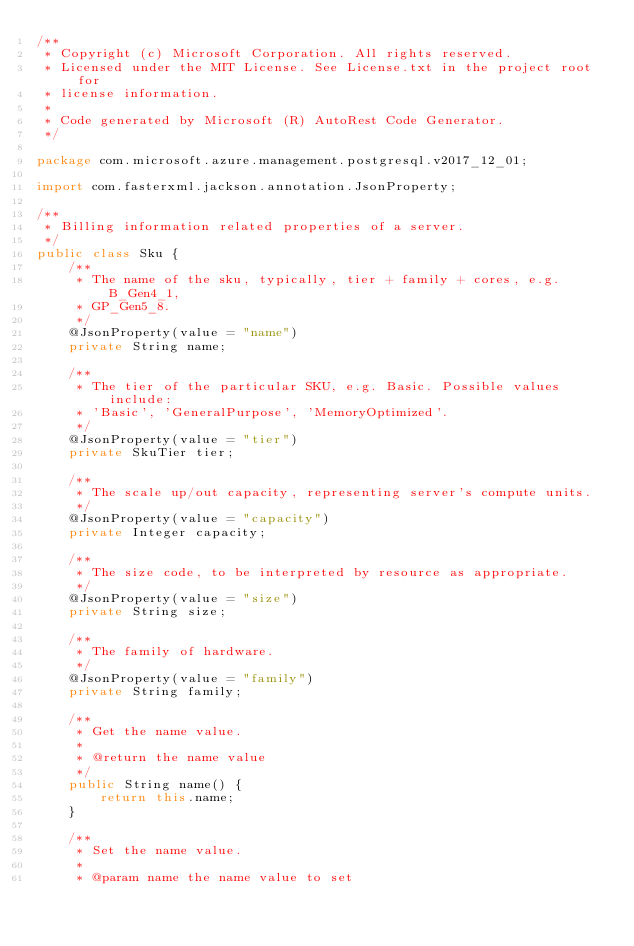<code> <loc_0><loc_0><loc_500><loc_500><_Java_>/**
 * Copyright (c) Microsoft Corporation. All rights reserved.
 * Licensed under the MIT License. See License.txt in the project root for
 * license information.
 *
 * Code generated by Microsoft (R) AutoRest Code Generator.
 */

package com.microsoft.azure.management.postgresql.v2017_12_01;

import com.fasterxml.jackson.annotation.JsonProperty;

/**
 * Billing information related properties of a server.
 */
public class Sku {
    /**
     * The name of the sku, typically, tier + family + cores, e.g. B_Gen4_1,
     * GP_Gen5_8.
     */
    @JsonProperty(value = "name")
    private String name;

    /**
     * The tier of the particular SKU, e.g. Basic. Possible values include:
     * 'Basic', 'GeneralPurpose', 'MemoryOptimized'.
     */
    @JsonProperty(value = "tier")
    private SkuTier tier;

    /**
     * The scale up/out capacity, representing server's compute units.
     */
    @JsonProperty(value = "capacity")
    private Integer capacity;

    /**
     * The size code, to be interpreted by resource as appropriate.
     */
    @JsonProperty(value = "size")
    private String size;

    /**
     * The family of hardware.
     */
    @JsonProperty(value = "family")
    private String family;

    /**
     * Get the name value.
     *
     * @return the name value
     */
    public String name() {
        return this.name;
    }

    /**
     * Set the name value.
     *
     * @param name the name value to set</code> 